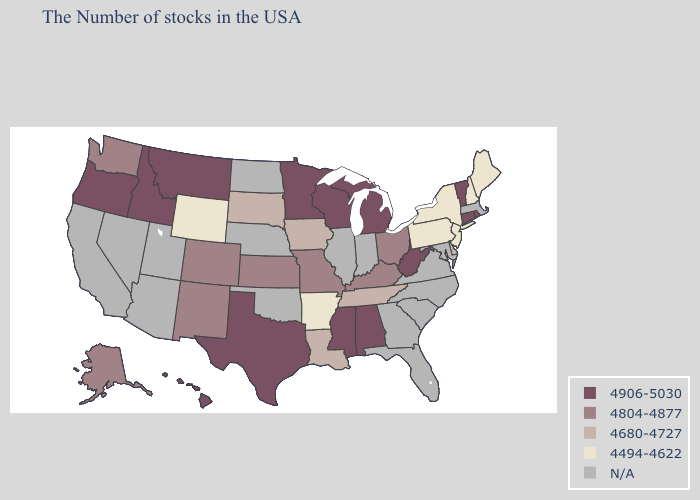Name the states that have a value in the range 4804-4877?
Keep it brief. Ohio, Kentucky, Missouri, Kansas, Colorado, New Mexico, Washington, Alaska. What is the highest value in the MidWest ?
Concise answer only. 4906-5030. Among the states that border Kentucky , does Tennessee have the lowest value?
Write a very short answer. Yes. What is the value of Louisiana?
Short answer required. 4680-4727. Does the map have missing data?
Answer briefly. Yes. What is the highest value in the South ?
Short answer required. 4906-5030. Name the states that have a value in the range 4494-4622?
Give a very brief answer. Maine, New Hampshire, New York, New Jersey, Pennsylvania, Arkansas, Wyoming. What is the highest value in states that border Tennessee?
Keep it brief. 4906-5030. Is the legend a continuous bar?
Short answer required. No. Name the states that have a value in the range 4494-4622?
Answer briefly. Maine, New Hampshire, New York, New Jersey, Pennsylvania, Arkansas, Wyoming. Does Kentucky have the highest value in the USA?
Answer briefly. No. What is the highest value in the USA?
Quick response, please. 4906-5030. Does Washington have the highest value in the West?
Quick response, please. No. 